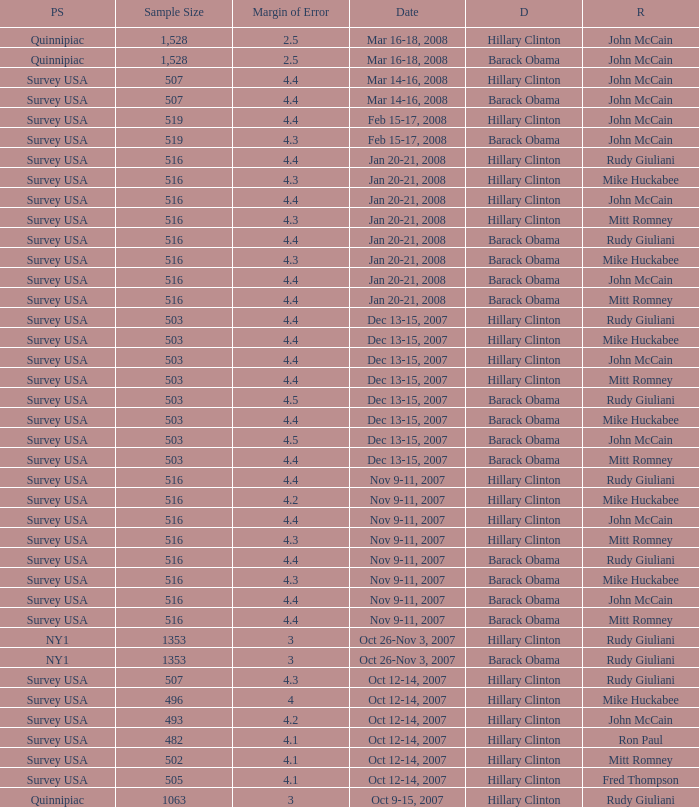Which democrat was elected in the poll with a sample size smaller than 516 where the republican opted was ron paul? Hillary Clinton. 